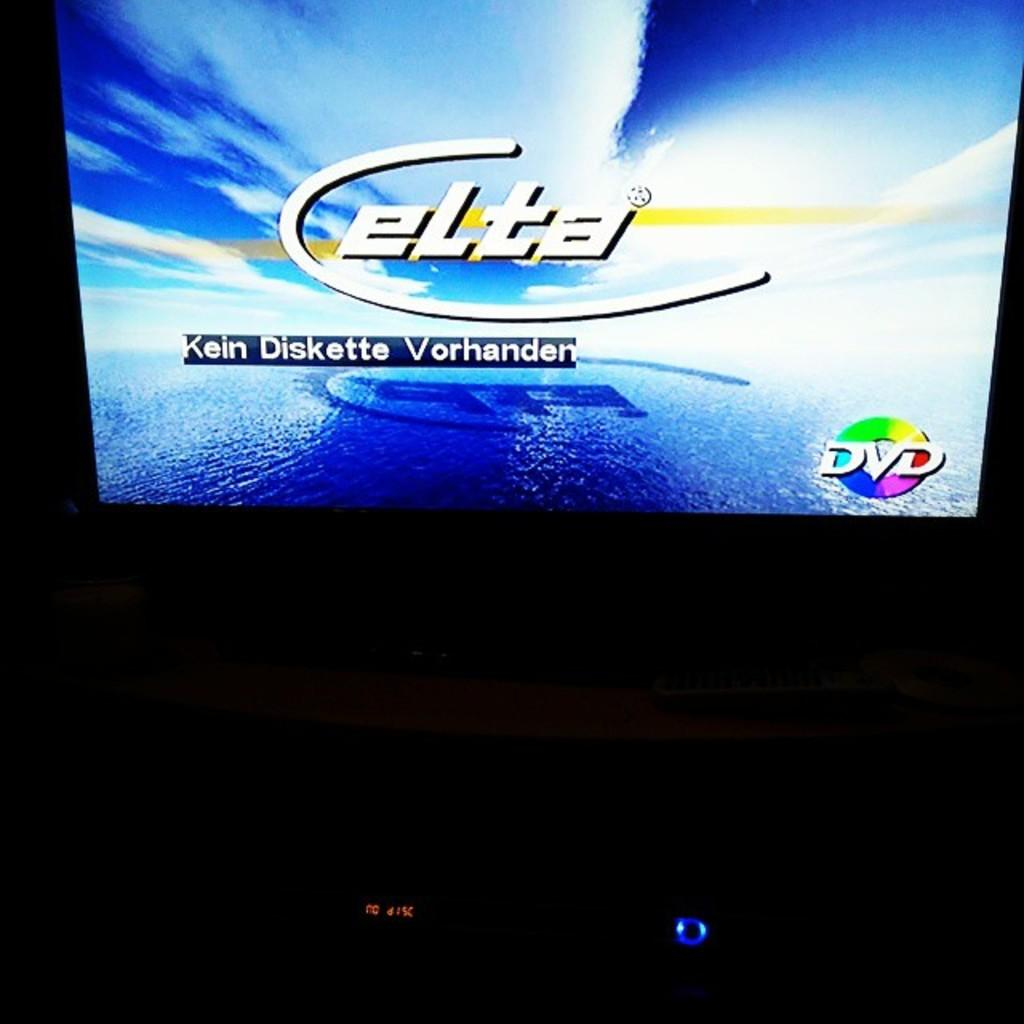<image>
Give a short and clear explanation of the subsequent image. an elta sign that is on a tv 